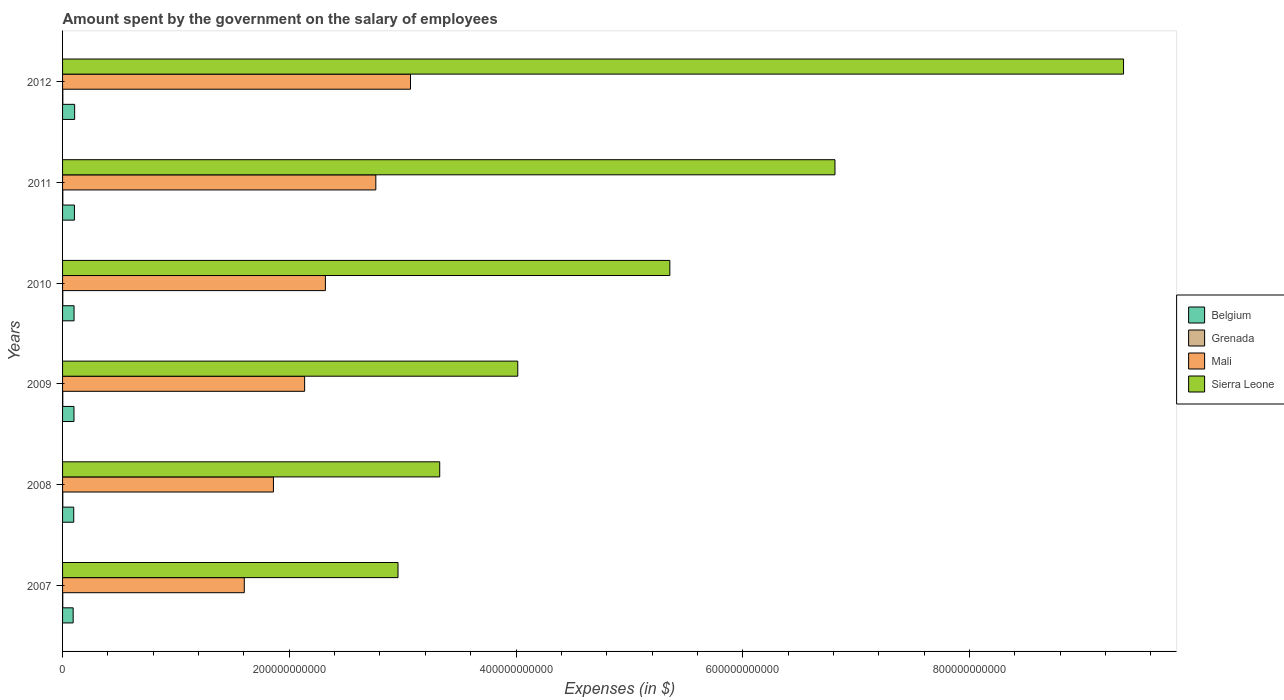How many different coloured bars are there?
Offer a terse response. 4. What is the label of the 4th group of bars from the top?
Provide a succinct answer. 2009. What is the amount spent on the salary of employees by the government in Sierra Leone in 2009?
Give a very brief answer. 4.02e+11. Across all years, what is the maximum amount spent on the salary of employees by the government in Belgium?
Offer a very short reply. 1.07e+1. Across all years, what is the minimum amount spent on the salary of employees by the government in Mali?
Your answer should be very brief. 1.60e+11. In which year was the amount spent on the salary of employees by the government in Mali maximum?
Ensure brevity in your answer.  2012. What is the total amount spent on the salary of employees by the government in Belgium in the graph?
Make the answer very short. 6.05e+1. What is the difference between the amount spent on the salary of employees by the government in Grenada in 2007 and that in 2011?
Provide a short and direct response. -6.32e+07. What is the difference between the amount spent on the salary of employees by the government in Mali in 2009 and the amount spent on the salary of employees by the government in Grenada in 2012?
Your answer should be compact. 2.13e+11. What is the average amount spent on the salary of employees by the government in Belgium per year?
Your answer should be compact. 1.01e+1. In the year 2012, what is the difference between the amount spent on the salary of employees by the government in Sierra Leone and amount spent on the salary of employees by the government in Grenada?
Keep it short and to the point. 9.36e+11. What is the ratio of the amount spent on the salary of employees by the government in Grenada in 2009 to that in 2010?
Give a very brief answer. 0.96. What is the difference between the highest and the second highest amount spent on the salary of employees by the government in Mali?
Offer a very short reply. 3.06e+1. What is the difference between the highest and the lowest amount spent on the salary of employees by the government in Grenada?
Provide a short and direct response. 6.88e+07. In how many years, is the amount spent on the salary of employees by the government in Sierra Leone greater than the average amount spent on the salary of employees by the government in Sierra Leone taken over all years?
Your answer should be compact. 3. Is it the case that in every year, the sum of the amount spent on the salary of employees by the government in Sierra Leone and amount spent on the salary of employees by the government in Mali is greater than the sum of amount spent on the salary of employees by the government in Grenada and amount spent on the salary of employees by the government in Belgium?
Offer a terse response. Yes. What does the 1st bar from the top in 2009 represents?
Provide a short and direct response. Sierra Leone. What does the 3rd bar from the bottom in 2007 represents?
Make the answer very short. Mali. Is it the case that in every year, the sum of the amount spent on the salary of employees by the government in Belgium and amount spent on the salary of employees by the government in Grenada is greater than the amount spent on the salary of employees by the government in Mali?
Your answer should be very brief. No. Are all the bars in the graph horizontal?
Offer a terse response. Yes. What is the difference between two consecutive major ticks on the X-axis?
Ensure brevity in your answer.  2.00e+11. Are the values on the major ticks of X-axis written in scientific E-notation?
Make the answer very short. No. Does the graph contain any zero values?
Your answer should be compact. No. Where does the legend appear in the graph?
Your response must be concise. Center right. What is the title of the graph?
Make the answer very short. Amount spent by the government on the salary of employees. Does "Small states" appear as one of the legend labels in the graph?
Offer a very short reply. No. What is the label or title of the X-axis?
Your answer should be compact. Expenses (in $). What is the Expenses (in $) in Belgium in 2007?
Offer a terse response. 9.34e+09. What is the Expenses (in $) of Grenada in 2007?
Keep it short and to the point. 1.58e+08. What is the Expenses (in $) in Mali in 2007?
Your answer should be very brief. 1.60e+11. What is the Expenses (in $) of Sierra Leone in 2007?
Keep it short and to the point. 2.96e+11. What is the Expenses (in $) of Belgium in 2008?
Ensure brevity in your answer.  9.86e+09. What is the Expenses (in $) of Grenada in 2008?
Offer a terse response. 2.01e+08. What is the Expenses (in $) of Mali in 2008?
Give a very brief answer. 1.86e+11. What is the Expenses (in $) in Sierra Leone in 2008?
Ensure brevity in your answer.  3.33e+11. What is the Expenses (in $) in Belgium in 2009?
Offer a very short reply. 1.01e+1. What is the Expenses (in $) of Grenada in 2009?
Ensure brevity in your answer.  1.91e+08. What is the Expenses (in $) in Mali in 2009?
Provide a succinct answer. 2.14e+11. What is the Expenses (in $) of Sierra Leone in 2009?
Give a very brief answer. 4.02e+11. What is the Expenses (in $) of Belgium in 2010?
Keep it short and to the point. 1.01e+1. What is the Expenses (in $) of Grenada in 2010?
Offer a terse response. 1.99e+08. What is the Expenses (in $) of Mali in 2010?
Your response must be concise. 2.32e+11. What is the Expenses (in $) in Sierra Leone in 2010?
Your answer should be very brief. 5.36e+11. What is the Expenses (in $) in Belgium in 2011?
Ensure brevity in your answer.  1.05e+1. What is the Expenses (in $) of Grenada in 2011?
Make the answer very short. 2.22e+08. What is the Expenses (in $) in Mali in 2011?
Give a very brief answer. 2.76e+11. What is the Expenses (in $) in Sierra Leone in 2011?
Your answer should be compact. 6.81e+11. What is the Expenses (in $) in Belgium in 2012?
Your answer should be compact. 1.07e+1. What is the Expenses (in $) of Grenada in 2012?
Your response must be concise. 2.27e+08. What is the Expenses (in $) of Mali in 2012?
Your answer should be compact. 3.07e+11. What is the Expenses (in $) of Sierra Leone in 2012?
Provide a short and direct response. 9.36e+11. Across all years, what is the maximum Expenses (in $) of Belgium?
Your answer should be compact. 1.07e+1. Across all years, what is the maximum Expenses (in $) of Grenada?
Provide a succinct answer. 2.27e+08. Across all years, what is the maximum Expenses (in $) in Mali?
Provide a succinct answer. 3.07e+11. Across all years, what is the maximum Expenses (in $) in Sierra Leone?
Give a very brief answer. 9.36e+11. Across all years, what is the minimum Expenses (in $) of Belgium?
Ensure brevity in your answer.  9.34e+09. Across all years, what is the minimum Expenses (in $) in Grenada?
Ensure brevity in your answer.  1.58e+08. Across all years, what is the minimum Expenses (in $) in Mali?
Your answer should be compact. 1.60e+11. Across all years, what is the minimum Expenses (in $) in Sierra Leone?
Your response must be concise. 2.96e+11. What is the total Expenses (in $) in Belgium in the graph?
Your answer should be very brief. 6.05e+1. What is the total Expenses (in $) of Grenada in the graph?
Your answer should be compact. 1.20e+09. What is the total Expenses (in $) of Mali in the graph?
Provide a short and direct response. 1.37e+12. What is the total Expenses (in $) of Sierra Leone in the graph?
Your response must be concise. 3.18e+12. What is the difference between the Expenses (in $) of Belgium in 2007 and that in 2008?
Your answer should be very brief. -5.14e+08. What is the difference between the Expenses (in $) in Grenada in 2007 and that in 2008?
Your response must be concise. -4.24e+07. What is the difference between the Expenses (in $) in Mali in 2007 and that in 2008?
Ensure brevity in your answer.  -2.57e+1. What is the difference between the Expenses (in $) of Sierra Leone in 2007 and that in 2008?
Give a very brief answer. -3.68e+1. What is the difference between the Expenses (in $) of Belgium in 2007 and that in 2009?
Make the answer very short. -7.34e+08. What is the difference between the Expenses (in $) in Grenada in 2007 and that in 2009?
Provide a succinct answer. -3.28e+07. What is the difference between the Expenses (in $) in Mali in 2007 and that in 2009?
Your answer should be compact. -5.32e+1. What is the difference between the Expenses (in $) of Sierra Leone in 2007 and that in 2009?
Ensure brevity in your answer.  -1.06e+11. What is the difference between the Expenses (in $) of Belgium in 2007 and that in 2010?
Your answer should be compact. -8.04e+08. What is the difference between the Expenses (in $) of Grenada in 2007 and that in 2010?
Give a very brief answer. -4.10e+07. What is the difference between the Expenses (in $) in Mali in 2007 and that in 2010?
Your response must be concise. -7.15e+1. What is the difference between the Expenses (in $) of Sierra Leone in 2007 and that in 2010?
Provide a short and direct response. -2.40e+11. What is the difference between the Expenses (in $) of Belgium in 2007 and that in 2011?
Give a very brief answer. -1.12e+09. What is the difference between the Expenses (in $) of Grenada in 2007 and that in 2011?
Your response must be concise. -6.32e+07. What is the difference between the Expenses (in $) in Mali in 2007 and that in 2011?
Keep it short and to the point. -1.16e+11. What is the difference between the Expenses (in $) in Sierra Leone in 2007 and that in 2011?
Offer a terse response. -3.85e+11. What is the difference between the Expenses (in $) of Belgium in 2007 and that in 2012?
Make the answer very short. -1.31e+09. What is the difference between the Expenses (in $) of Grenada in 2007 and that in 2012?
Your answer should be compact. -6.88e+07. What is the difference between the Expenses (in $) of Mali in 2007 and that in 2012?
Provide a succinct answer. -1.47e+11. What is the difference between the Expenses (in $) of Sierra Leone in 2007 and that in 2012?
Offer a terse response. -6.40e+11. What is the difference between the Expenses (in $) of Belgium in 2008 and that in 2009?
Keep it short and to the point. -2.20e+08. What is the difference between the Expenses (in $) of Grenada in 2008 and that in 2009?
Keep it short and to the point. 9.60e+06. What is the difference between the Expenses (in $) of Mali in 2008 and that in 2009?
Keep it short and to the point. -2.75e+1. What is the difference between the Expenses (in $) of Sierra Leone in 2008 and that in 2009?
Provide a succinct answer. -6.88e+1. What is the difference between the Expenses (in $) in Belgium in 2008 and that in 2010?
Your answer should be very brief. -2.89e+08. What is the difference between the Expenses (in $) in Grenada in 2008 and that in 2010?
Offer a very short reply. 1.40e+06. What is the difference between the Expenses (in $) of Mali in 2008 and that in 2010?
Your response must be concise. -4.58e+1. What is the difference between the Expenses (in $) of Sierra Leone in 2008 and that in 2010?
Offer a very short reply. -2.03e+11. What is the difference between the Expenses (in $) in Belgium in 2008 and that in 2011?
Your response must be concise. -6.05e+08. What is the difference between the Expenses (in $) in Grenada in 2008 and that in 2011?
Provide a short and direct response. -2.08e+07. What is the difference between the Expenses (in $) of Mali in 2008 and that in 2011?
Offer a very short reply. -9.03e+1. What is the difference between the Expenses (in $) in Sierra Leone in 2008 and that in 2011?
Your response must be concise. -3.49e+11. What is the difference between the Expenses (in $) of Belgium in 2008 and that in 2012?
Provide a succinct answer. -7.94e+08. What is the difference between the Expenses (in $) of Grenada in 2008 and that in 2012?
Make the answer very short. -2.64e+07. What is the difference between the Expenses (in $) in Mali in 2008 and that in 2012?
Provide a succinct answer. -1.21e+11. What is the difference between the Expenses (in $) of Sierra Leone in 2008 and that in 2012?
Your response must be concise. -6.03e+11. What is the difference between the Expenses (in $) in Belgium in 2009 and that in 2010?
Your response must be concise. -6.91e+07. What is the difference between the Expenses (in $) of Grenada in 2009 and that in 2010?
Provide a succinct answer. -8.20e+06. What is the difference between the Expenses (in $) in Mali in 2009 and that in 2010?
Ensure brevity in your answer.  -1.83e+1. What is the difference between the Expenses (in $) in Sierra Leone in 2009 and that in 2010?
Make the answer very short. -1.34e+11. What is the difference between the Expenses (in $) of Belgium in 2009 and that in 2011?
Offer a very short reply. -3.85e+08. What is the difference between the Expenses (in $) in Grenada in 2009 and that in 2011?
Provide a succinct answer. -3.04e+07. What is the difference between the Expenses (in $) of Mali in 2009 and that in 2011?
Ensure brevity in your answer.  -6.28e+1. What is the difference between the Expenses (in $) of Sierra Leone in 2009 and that in 2011?
Make the answer very short. -2.80e+11. What is the difference between the Expenses (in $) of Belgium in 2009 and that in 2012?
Your response must be concise. -5.74e+08. What is the difference between the Expenses (in $) of Grenada in 2009 and that in 2012?
Offer a terse response. -3.60e+07. What is the difference between the Expenses (in $) in Mali in 2009 and that in 2012?
Your answer should be compact. -9.34e+1. What is the difference between the Expenses (in $) of Sierra Leone in 2009 and that in 2012?
Make the answer very short. -5.34e+11. What is the difference between the Expenses (in $) in Belgium in 2010 and that in 2011?
Your answer should be very brief. -3.16e+08. What is the difference between the Expenses (in $) of Grenada in 2010 and that in 2011?
Your response must be concise. -2.22e+07. What is the difference between the Expenses (in $) of Mali in 2010 and that in 2011?
Ensure brevity in your answer.  -4.45e+1. What is the difference between the Expenses (in $) of Sierra Leone in 2010 and that in 2011?
Offer a very short reply. -1.46e+11. What is the difference between the Expenses (in $) of Belgium in 2010 and that in 2012?
Ensure brevity in your answer.  -5.04e+08. What is the difference between the Expenses (in $) in Grenada in 2010 and that in 2012?
Ensure brevity in your answer.  -2.78e+07. What is the difference between the Expenses (in $) in Mali in 2010 and that in 2012?
Offer a very short reply. -7.51e+1. What is the difference between the Expenses (in $) of Sierra Leone in 2010 and that in 2012?
Your answer should be compact. -4.00e+11. What is the difference between the Expenses (in $) of Belgium in 2011 and that in 2012?
Ensure brevity in your answer.  -1.89e+08. What is the difference between the Expenses (in $) in Grenada in 2011 and that in 2012?
Provide a succinct answer. -5.60e+06. What is the difference between the Expenses (in $) in Mali in 2011 and that in 2012?
Your answer should be compact. -3.06e+1. What is the difference between the Expenses (in $) in Sierra Leone in 2011 and that in 2012?
Ensure brevity in your answer.  -2.55e+11. What is the difference between the Expenses (in $) of Belgium in 2007 and the Expenses (in $) of Grenada in 2008?
Offer a terse response. 9.14e+09. What is the difference between the Expenses (in $) in Belgium in 2007 and the Expenses (in $) in Mali in 2008?
Keep it short and to the point. -1.77e+11. What is the difference between the Expenses (in $) in Belgium in 2007 and the Expenses (in $) in Sierra Leone in 2008?
Offer a terse response. -3.23e+11. What is the difference between the Expenses (in $) in Grenada in 2007 and the Expenses (in $) in Mali in 2008?
Ensure brevity in your answer.  -1.86e+11. What is the difference between the Expenses (in $) of Grenada in 2007 and the Expenses (in $) of Sierra Leone in 2008?
Your answer should be very brief. -3.33e+11. What is the difference between the Expenses (in $) in Mali in 2007 and the Expenses (in $) in Sierra Leone in 2008?
Your answer should be compact. -1.72e+11. What is the difference between the Expenses (in $) of Belgium in 2007 and the Expenses (in $) of Grenada in 2009?
Your response must be concise. 9.15e+09. What is the difference between the Expenses (in $) of Belgium in 2007 and the Expenses (in $) of Mali in 2009?
Your answer should be compact. -2.04e+11. What is the difference between the Expenses (in $) of Belgium in 2007 and the Expenses (in $) of Sierra Leone in 2009?
Offer a terse response. -3.92e+11. What is the difference between the Expenses (in $) in Grenada in 2007 and the Expenses (in $) in Mali in 2009?
Provide a succinct answer. -2.13e+11. What is the difference between the Expenses (in $) of Grenada in 2007 and the Expenses (in $) of Sierra Leone in 2009?
Your response must be concise. -4.01e+11. What is the difference between the Expenses (in $) in Mali in 2007 and the Expenses (in $) in Sierra Leone in 2009?
Make the answer very short. -2.41e+11. What is the difference between the Expenses (in $) in Belgium in 2007 and the Expenses (in $) in Grenada in 2010?
Ensure brevity in your answer.  9.14e+09. What is the difference between the Expenses (in $) in Belgium in 2007 and the Expenses (in $) in Mali in 2010?
Offer a very short reply. -2.22e+11. What is the difference between the Expenses (in $) of Belgium in 2007 and the Expenses (in $) of Sierra Leone in 2010?
Keep it short and to the point. -5.26e+11. What is the difference between the Expenses (in $) of Grenada in 2007 and the Expenses (in $) of Mali in 2010?
Offer a terse response. -2.32e+11. What is the difference between the Expenses (in $) of Grenada in 2007 and the Expenses (in $) of Sierra Leone in 2010?
Offer a terse response. -5.36e+11. What is the difference between the Expenses (in $) of Mali in 2007 and the Expenses (in $) of Sierra Leone in 2010?
Ensure brevity in your answer.  -3.75e+11. What is the difference between the Expenses (in $) in Belgium in 2007 and the Expenses (in $) in Grenada in 2011?
Your answer should be very brief. 9.12e+09. What is the difference between the Expenses (in $) in Belgium in 2007 and the Expenses (in $) in Mali in 2011?
Provide a short and direct response. -2.67e+11. What is the difference between the Expenses (in $) in Belgium in 2007 and the Expenses (in $) in Sierra Leone in 2011?
Provide a short and direct response. -6.72e+11. What is the difference between the Expenses (in $) in Grenada in 2007 and the Expenses (in $) in Mali in 2011?
Your response must be concise. -2.76e+11. What is the difference between the Expenses (in $) in Grenada in 2007 and the Expenses (in $) in Sierra Leone in 2011?
Offer a very short reply. -6.81e+11. What is the difference between the Expenses (in $) in Mali in 2007 and the Expenses (in $) in Sierra Leone in 2011?
Offer a very short reply. -5.21e+11. What is the difference between the Expenses (in $) of Belgium in 2007 and the Expenses (in $) of Grenada in 2012?
Ensure brevity in your answer.  9.12e+09. What is the difference between the Expenses (in $) of Belgium in 2007 and the Expenses (in $) of Mali in 2012?
Ensure brevity in your answer.  -2.98e+11. What is the difference between the Expenses (in $) of Belgium in 2007 and the Expenses (in $) of Sierra Leone in 2012?
Your answer should be very brief. -9.27e+11. What is the difference between the Expenses (in $) in Grenada in 2007 and the Expenses (in $) in Mali in 2012?
Your answer should be very brief. -3.07e+11. What is the difference between the Expenses (in $) in Grenada in 2007 and the Expenses (in $) in Sierra Leone in 2012?
Offer a very short reply. -9.36e+11. What is the difference between the Expenses (in $) of Mali in 2007 and the Expenses (in $) of Sierra Leone in 2012?
Provide a succinct answer. -7.76e+11. What is the difference between the Expenses (in $) in Belgium in 2008 and the Expenses (in $) in Grenada in 2009?
Offer a very short reply. 9.67e+09. What is the difference between the Expenses (in $) of Belgium in 2008 and the Expenses (in $) of Mali in 2009?
Provide a short and direct response. -2.04e+11. What is the difference between the Expenses (in $) in Belgium in 2008 and the Expenses (in $) in Sierra Leone in 2009?
Provide a short and direct response. -3.92e+11. What is the difference between the Expenses (in $) of Grenada in 2008 and the Expenses (in $) of Mali in 2009?
Provide a succinct answer. -2.13e+11. What is the difference between the Expenses (in $) in Grenada in 2008 and the Expenses (in $) in Sierra Leone in 2009?
Offer a terse response. -4.01e+11. What is the difference between the Expenses (in $) of Mali in 2008 and the Expenses (in $) of Sierra Leone in 2009?
Make the answer very short. -2.16e+11. What is the difference between the Expenses (in $) of Belgium in 2008 and the Expenses (in $) of Grenada in 2010?
Offer a terse response. 9.66e+09. What is the difference between the Expenses (in $) in Belgium in 2008 and the Expenses (in $) in Mali in 2010?
Give a very brief answer. -2.22e+11. What is the difference between the Expenses (in $) of Belgium in 2008 and the Expenses (in $) of Sierra Leone in 2010?
Your answer should be compact. -5.26e+11. What is the difference between the Expenses (in $) in Grenada in 2008 and the Expenses (in $) in Mali in 2010?
Provide a succinct answer. -2.32e+11. What is the difference between the Expenses (in $) of Grenada in 2008 and the Expenses (in $) of Sierra Leone in 2010?
Provide a short and direct response. -5.35e+11. What is the difference between the Expenses (in $) in Mali in 2008 and the Expenses (in $) in Sierra Leone in 2010?
Ensure brevity in your answer.  -3.50e+11. What is the difference between the Expenses (in $) in Belgium in 2008 and the Expenses (in $) in Grenada in 2011?
Offer a very short reply. 9.64e+09. What is the difference between the Expenses (in $) in Belgium in 2008 and the Expenses (in $) in Mali in 2011?
Your answer should be compact. -2.66e+11. What is the difference between the Expenses (in $) in Belgium in 2008 and the Expenses (in $) in Sierra Leone in 2011?
Provide a succinct answer. -6.71e+11. What is the difference between the Expenses (in $) in Grenada in 2008 and the Expenses (in $) in Mali in 2011?
Your answer should be very brief. -2.76e+11. What is the difference between the Expenses (in $) of Grenada in 2008 and the Expenses (in $) of Sierra Leone in 2011?
Provide a succinct answer. -6.81e+11. What is the difference between the Expenses (in $) in Mali in 2008 and the Expenses (in $) in Sierra Leone in 2011?
Provide a succinct answer. -4.95e+11. What is the difference between the Expenses (in $) of Belgium in 2008 and the Expenses (in $) of Grenada in 2012?
Give a very brief answer. 9.63e+09. What is the difference between the Expenses (in $) of Belgium in 2008 and the Expenses (in $) of Mali in 2012?
Give a very brief answer. -2.97e+11. What is the difference between the Expenses (in $) in Belgium in 2008 and the Expenses (in $) in Sierra Leone in 2012?
Make the answer very short. -9.26e+11. What is the difference between the Expenses (in $) of Grenada in 2008 and the Expenses (in $) of Mali in 2012?
Provide a succinct answer. -3.07e+11. What is the difference between the Expenses (in $) of Grenada in 2008 and the Expenses (in $) of Sierra Leone in 2012?
Offer a terse response. -9.36e+11. What is the difference between the Expenses (in $) of Mali in 2008 and the Expenses (in $) of Sierra Leone in 2012?
Keep it short and to the point. -7.50e+11. What is the difference between the Expenses (in $) in Belgium in 2009 and the Expenses (in $) in Grenada in 2010?
Provide a succinct answer. 9.88e+09. What is the difference between the Expenses (in $) in Belgium in 2009 and the Expenses (in $) in Mali in 2010?
Your answer should be compact. -2.22e+11. What is the difference between the Expenses (in $) in Belgium in 2009 and the Expenses (in $) in Sierra Leone in 2010?
Provide a short and direct response. -5.26e+11. What is the difference between the Expenses (in $) in Grenada in 2009 and the Expenses (in $) in Mali in 2010?
Give a very brief answer. -2.32e+11. What is the difference between the Expenses (in $) in Grenada in 2009 and the Expenses (in $) in Sierra Leone in 2010?
Your answer should be very brief. -5.35e+11. What is the difference between the Expenses (in $) in Mali in 2009 and the Expenses (in $) in Sierra Leone in 2010?
Your answer should be compact. -3.22e+11. What is the difference between the Expenses (in $) of Belgium in 2009 and the Expenses (in $) of Grenada in 2011?
Offer a very short reply. 9.86e+09. What is the difference between the Expenses (in $) in Belgium in 2009 and the Expenses (in $) in Mali in 2011?
Ensure brevity in your answer.  -2.66e+11. What is the difference between the Expenses (in $) of Belgium in 2009 and the Expenses (in $) of Sierra Leone in 2011?
Ensure brevity in your answer.  -6.71e+11. What is the difference between the Expenses (in $) in Grenada in 2009 and the Expenses (in $) in Mali in 2011?
Ensure brevity in your answer.  -2.76e+11. What is the difference between the Expenses (in $) in Grenada in 2009 and the Expenses (in $) in Sierra Leone in 2011?
Your answer should be very brief. -6.81e+11. What is the difference between the Expenses (in $) of Mali in 2009 and the Expenses (in $) of Sierra Leone in 2011?
Make the answer very short. -4.68e+11. What is the difference between the Expenses (in $) in Belgium in 2009 and the Expenses (in $) in Grenada in 2012?
Give a very brief answer. 9.85e+09. What is the difference between the Expenses (in $) in Belgium in 2009 and the Expenses (in $) in Mali in 2012?
Offer a very short reply. -2.97e+11. What is the difference between the Expenses (in $) of Belgium in 2009 and the Expenses (in $) of Sierra Leone in 2012?
Ensure brevity in your answer.  -9.26e+11. What is the difference between the Expenses (in $) of Grenada in 2009 and the Expenses (in $) of Mali in 2012?
Provide a succinct answer. -3.07e+11. What is the difference between the Expenses (in $) of Grenada in 2009 and the Expenses (in $) of Sierra Leone in 2012?
Your answer should be compact. -9.36e+11. What is the difference between the Expenses (in $) of Mali in 2009 and the Expenses (in $) of Sierra Leone in 2012?
Make the answer very short. -7.22e+11. What is the difference between the Expenses (in $) of Belgium in 2010 and the Expenses (in $) of Grenada in 2011?
Offer a very short reply. 9.92e+09. What is the difference between the Expenses (in $) in Belgium in 2010 and the Expenses (in $) in Mali in 2011?
Provide a short and direct response. -2.66e+11. What is the difference between the Expenses (in $) in Belgium in 2010 and the Expenses (in $) in Sierra Leone in 2011?
Ensure brevity in your answer.  -6.71e+11. What is the difference between the Expenses (in $) of Grenada in 2010 and the Expenses (in $) of Mali in 2011?
Provide a short and direct response. -2.76e+11. What is the difference between the Expenses (in $) of Grenada in 2010 and the Expenses (in $) of Sierra Leone in 2011?
Offer a terse response. -6.81e+11. What is the difference between the Expenses (in $) in Mali in 2010 and the Expenses (in $) in Sierra Leone in 2011?
Provide a succinct answer. -4.50e+11. What is the difference between the Expenses (in $) of Belgium in 2010 and the Expenses (in $) of Grenada in 2012?
Ensure brevity in your answer.  9.92e+09. What is the difference between the Expenses (in $) in Belgium in 2010 and the Expenses (in $) in Mali in 2012?
Your response must be concise. -2.97e+11. What is the difference between the Expenses (in $) in Belgium in 2010 and the Expenses (in $) in Sierra Leone in 2012?
Make the answer very short. -9.26e+11. What is the difference between the Expenses (in $) in Grenada in 2010 and the Expenses (in $) in Mali in 2012?
Your response must be concise. -3.07e+11. What is the difference between the Expenses (in $) in Grenada in 2010 and the Expenses (in $) in Sierra Leone in 2012?
Give a very brief answer. -9.36e+11. What is the difference between the Expenses (in $) of Mali in 2010 and the Expenses (in $) of Sierra Leone in 2012?
Your response must be concise. -7.04e+11. What is the difference between the Expenses (in $) of Belgium in 2011 and the Expenses (in $) of Grenada in 2012?
Give a very brief answer. 1.02e+1. What is the difference between the Expenses (in $) in Belgium in 2011 and the Expenses (in $) in Mali in 2012?
Offer a very short reply. -2.96e+11. What is the difference between the Expenses (in $) in Belgium in 2011 and the Expenses (in $) in Sierra Leone in 2012?
Your response must be concise. -9.25e+11. What is the difference between the Expenses (in $) of Grenada in 2011 and the Expenses (in $) of Mali in 2012?
Make the answer very short. -3.07e+11. What is the difference between the Expenses (in $) of Grenada in 2011 and the Expenses (in $) of Sierra Leone in 2012?
Provide a short and direct response. -9.36e+11. What is the difference between the Expenses (in $) of Mali in 2011 and the Expenses (in $) of Sierra Leone in 2012?
Your response must be concise. -6.60e+11. What is the average Expenses (in $) in Belgium per year?
Keep it short and to the point. 1.01e+1. What is the average Expenses (in $) in Grenada per year?
Keep it short and to the point. 2.00e+08. What is the average Expenses (in $) in Mali per year?
Your answer should be compact. 2.29e+11. What is the average Expenses (in $) in Sierra Leone per year?
Your response must be concise. 5.31e+11. In the year 2007, what is the difference between the Expenses (in $) of Belgium and Expenses (in $) of Grenada?
Ensure brevity in your answer.  9.18e+09. In the year 2007, what is the difference between the Expenses (in $) in Belgium and Expenses (in $) in Mali?
Give a very brief answer. -1.51e+11. In the year 2007, what is the difference between the Expenses (in $) in Belgium and Expenses (in $) in Sierra Leone?
Give a very brief answer. -2.87e+11. In the year 2007, what is the difference between the Expenses (in $) in Grenada and Expenses (in $) in Mali?
Provide a succinct answer. -1.60e+11. In the year 2007, what is the difference between the Expenses (in $) in Grenada and Expenses (in $) in Sierra Leone?
Give a very brief answer. -2.96e+11. In the year 2007, what is the difference between the Expenses (in $) of Mali and Expenses (in $) of Sierra Leone?
Your response must be concise. -1.36e+11. In the year 2008, what is the difference between the Expenses (in $) in Belgium and Expenses (in $) in Grenada?
Offer a terse response. 9.66e+09. In the year 2008, what is the difference between the Expenses (in $) in Belgium and Expenses (in $) in Mali?
Offer a very short reply. -1.76e+11. In the year 2008, what is the difference between the Expenses (in $) in Belgium and Expenses (in $) in Sierra Leone?
Offer a terse response. -3.23e+11. In the year 2008, what is the difference between the Expenses (in $) of Grenada and Expenses (in $) of Mali?
Give a very brief answer. -1.86e+11. In the year 2008, what is the difference between the Expenses (in $) in Grenada and Expenses (in $) in Sierra Leone?
Make the answer very short. -3.32e+11. In the year 2008, what is the difference between the Expenses (in $) of Mali and Expenses (in $) of Sierra Leone?
Give a very brief answer. -1.47e+11. In the year 2009, what is the difference between the Expenses (in $) of Belgium and Expenses (in $) of Grenada?
Offer a terse response. 9.89e+09. In the year 2009, what is the difference between the Expenses (in $) of Belgium and Expenses (in $) of Mali?
Offer a very short reply. -2.03e+11. In the year 2009, what is the difference between the Expenses (in $) of Belgium and Expenses (in $) of Sierra Leone?
Offer a very short reply. -3.91e+11. In the year 2009, what is the difference between the Expenses (in $) in Grenada and Expenses (in $) in Mali?
Make the answer very short. -2.13e+11. In the year 2009, what is the difference between the Expenses (in $) of Grenada and Expenses (in $) of Sierra Leone?
Offer a terse response. -4.01e+11. In the year 2009, what is the difference between the Expenses (in $) in Mali and Expenses (in $) in Sierra Leone?
Keep it short and to the point. -1.88e+11. In the year 2010, what is the difference between the Expenses (in $) of Belgium and Expenses (in $) of Grenada?
Your answer should be compact. 9.95e+09. In the year 2010, what is the difference between the Expenses (in $) in Belgium and Expenses (in $) in Mali?
Give a very brief answer. -2.22e+11. In the year 2010, what is the difference between the Expenses (in $) in Belgium and Expenses (in $) in Sierra Leone?
Provide a short and direct response. -5.26e+11. In the year 2010, what is the difference between the Expenses (in $) of Grenada and Expenses (in $) of Mali?
Your response must be concise. -2.32e+11. In the year 2010, what is the difference between the Expenses (in $) in Grenada and Expenses (in $) in Sierra Leone?
Your answer should be compact. -5.35e+11. In the year 2010, what is the difference between the Expenses (in $) of Mali and Expenses (in $) of Sierra Leone?
Your answer should be compact. -3.04e+11. In the year 2011, what is the difference between the Expenses (in $) of Belgium and Expenses (in $) of Grenada?
Offer a very short reply. 1.02e+1. In the year 2011, what is the difference between the Expenses (in $) in Belgium and Expenses (in $) in Mali?
Make the answer very short. -2.66e+11. In the year 2011, what is the difference between the Expenses (in $) of Belgium and Expenses (in $) of Sierra Leone?
Provide a succinct answer. -6.71e+11. In the year 2011, what is the difference between the Expenses (in $) in Grenada and Expenses (in $) in Mali?
Offer a very short reply. -2.76e+11. In the year 2011, what is the difference between the Expenses (in $) in Grenada and Expenses (in $) in Sierra Leone?
Offer a terse response. -6.81e+11. In the year 2011, what is the difference between the Expenses (in $) in Mali and Expenses (in $) in Sierra Leone?
Offer a terse response. -4.05e+11. In the year 2012, what is the difference between the Expenses (in $) in Belgium and Expenses (in $) in Grenada?
Provide a succinct answer. 1.04e+1. In the year 2012, what is the difference between the Expenses (in $) in Belgium and Expenses (in $) in Mali?
Provide a short and direct response. -2.96e+11. In the year 2012, what is the difference between the Expenses (in $) of Belgium and Expenses (in $) of Sierra Leone?
Your answer should be very brief. -9.25e+11. In the year 2012, what is the difference between the Expenses (in $) of Grenada and Expenses (in $) of Mali?
Give a very brief answer. -3.07e+11. In the year 2012, what is the difference between the Expenses (in $) of Grenada and Expenses (in $) of Sierra Leone?
Provide a succinct answer. -9.36e+11. In the year 2012, what is the difference between the Expenses (in $) of Mali and Expenses (in $) of Sierra Leone?
Keep it short and to the point. -6.29e+11. What is the ratio of the Expenses (in $) in Belgium in 2007 to that in 2008?
Keep it short and to the point. 0.95. What is the ratio of the Expenses (in $) in Grenada in 2007 to that in 2008?
Provide a short and direct response. 0.79. What is the ratio of the Expenses (in $) of Mali in 2007 to that in 2008?
Give a very brief answer. 0.86. What is the ratio of the Expenses (in $) of Sierra Leone in 2007 to that in 2008?
Offer a terse response. 0.89. What is the ratio of the Expenses (in $) of Belgium in 2007 to that in 2009?
Your response must be concise. 0.93. What is the ratio of the Expenses (in $) of Grenada in 2007 to that in 2009?
Your answer should be very brief. 0.83. What is the ratio of the Expenses (in $) of Mali in 2007 to that in 2009?
Provide a short and direct response. 0.75. What is the ratio of the Expenses (in $) of Sierra Leone in 2007 to that in 2009?
Your answer should be compact. 0.74. What is the ratio of the Expenses (in $) in Belgium in 2007 to that in 2010?
Ensure brevity in your answer.  0.92. What is the ratio of the Expenses (in $) of Grenada in 2007 to that in 2010?
Make the answer very short. 0.79. What is the ratio of the Expenses (in $) in Mali in 2007 to that in 2010?
Your answer should be very brief. 0.69. What is the ratio of the Expenses (in $) of Sierra Leone in 2007 to that in 2010?
Ensure brevity in your answer.  0.55. What is the ratio of the Expenses (in $) of Belgium in 2007 to that in 2011?
Provide a short and direct response. 0.89. What is the ratio of the Expenses (in $) in Grenada in 2007 to that in 2011?
Your response must be concise. 0.71. What is the ratio of the Expenses (in $) of Mali in 2007 to that in 2011?
Ensure brevity in your answer.  0.58. What is the ratio of the Expenses (in $) in Sierra Leone in 2007 to that in 2011?
Give a very brief answer. 0.43. What is the ratio of the Expenses (in $) of Belgium in 2007 to that in 2012?
Your answer should be very brief. 0.88. What is the ratio of the Expenses (in $) in Grenada in 2007 to that in 2012?
Make the answer very short. 0.7. What is the ratio of the Expenses (in $) in Mali in 2007 to that in 2012?
Keep it short and to the point. 0.52. What is the ratio of the Expenses (in $) in Sierra Leone in 2007 to that in 2012?
Give a very brief answer. 0.32. What is the ratio of the Expenses (in $) in Belgium in 2008 to that in 2009?
Keep it short and to the point. 0.98. What is the ratio of the Expenses (in $) of Grenada in 2008 to that in 2009?
Your answer should be compact. 1.05. What is the ratio of the Expenses (in $) of Mali in 2008 to that in 2009?
Offer a very short reply. 0.87. What is the ratio of the Expenses (in $) of Sierra Leone in 2008 to that in 2009?
Your answer should be compact. 0.83. What is the ratio of the Expenses (in $) of Belgium in 2008 to that in 2010?
Make the answer very short. 0.97. What is the ratio of the Expenses (in $) in Mali in 2008 to that in 2010?
Offer a terse response. 0.8. What is the ratio of the Expenses (in $) of Sierra Leone in 2008 to that in 2010?
Your answer should be compact. 0.62. What is the ratio of the Expenses (in $) in Belgium in 2008 to that in 2011?
Provide a short and direct response. 0.94. What is the ratio of the Expenses (in $) in Grenada in 2008 to that in 2011?
Your answer should be very brief. 0.91. What is the ratio of the Expenses (in $) in Mali in 2008 to that in 2011?
Offer a very short reply. 0.67. What is the ratio of the Expenses (in $) in Sierra Leone in 2008 to that in 2011?
Ensure brevity in your answer.  0.49. What is the ratio of the Expenses (in $) in Belgium in 2008 to that in 2012?
Your response must be concise. 0.93. What is the ratio of the Expenses (in $) in Grenada in 2008 to that in 2012?
Your answer should be compact. 0.88. What is the ratio of the Expenses (in $) of Mali in 2008 to that in 2012?
Offer a terse response. 0.61. What is the ratio of the Expenses (in $) in Sierra Leone in 2008 to that in 2012?
Your answer should be very brief. 0.36. What is the ratio of the Expenses (in $) in Grenada in 2009 to that in 2010?
Keep it short and to the point. 0.96. What is the ratio of the Expenses (in $) in Mali in 2009 to that in 2010?
Keep it short and to the point. 0.92. What is the ratio of the Expenses (in $) in Sierra Leone in 2009 to that in 2010?
Provide a short and direct response. 0.75. What is the ratio of the Expenses (in $) in Belgium in 2009 to that in 2011?
Provide a short and direct response. 0.96. What is the ratio of the Expenses (in $) in Grenada in 2009 to that in 2011?
Ensure brevity in your answer.  0.86. What is the ratio of the Expenses (in $) of Mali in 2009 to that in 2011?
Make the answer very short. 0.77. What is the ratio of the Expenses (in $) in Sierra Leone in 2009 to that in 2011?
Keep it short and to the point. 0.59. What is the ratio of the Expenses (in $) of Belgium in 2009 to that in 2012?
Your answer should be compact. 0.95. What is the ratio of the Expenses (in $) in Grenada in 2009 to that in 2012?
Provide a succinct answer. 0.84. What is the ratio of the Expenses (in $) of Mali in 2009 to that in 2012?
Provide a short and direct response. 0.7. What is the ratio of the Expenses (in $) in Sierra Leone in 2009 to that in 2012?
Your answer should be compact. 0.43. What is the ratio of the Expenses (in $) of Belgium in 2010 to that in 2011?
Offer a terse response. 0.97. What is the ratio of the Expenses (in $) of Grenada in 2010 to that in 2011?
Offer a terse response. 0.9. What is the ratio of the Expenses (in $) in Mali in 2010 to that in 2011?
Offer a very short reply. 0.84. What is the ratio of the Expenses (in $) in Sierra Leone in 2010 to that in 2011?
Give a very brief answer. 0.79. What is the ratio of the Expenses (in $) in Belgium in 2010 to that in 2012?
Provide a succinct answer. 0.95. What is the ratio of the Expenses (in $) in Grenada in 2010 to that in 2012?
Offer a very short reply. 0.88. What is the ratio of the Expenses (in $) in Mali in 2010 to that in 2012?
Offer a very short reply. 0.76. What is the ratio of the Expenses (in $) in Sierra Leone in 2010 to that in 2012?
Your response must be concise. 0.57. What is the ratio of the Expenses (in $) in Belgium in 2011 to that in 2012?
Provide a succinct answer. 0.98. What is the ratio of the Expenses (in $) in Grenada in 2011 to that in 2012?
Make the answer very short. 0.98. What is the ratio of the Expenses (in $) in Mali in 2011 to that in 2012?
Offer a very short reply. 0.9. What is the ratio of the Expenses (in $) of Sierra Leone in 2011 to that in 2012?
Keep it short and to the point. 0.73. What is the difference between the highest and the second highest Expenses (in $) in Belgium?
Make the answer very short. 1.89e+08. What is the difference between the highest and the second highest Expenses (in $) of Grenada?
Provide a short and direct response. 5.60e+06. What is the difference between the highest and the second highest Expenses (in $) of Mali?
Your answer should be compact. 3.06e+1. What is the difference between the highest and the second highest Expenses (in $) of Sierra Leone?
Provide a succinct answer. 2.55e+11. What is the difference between the highest and the lowest Expenses (in $) in Belgium?
Give a very brief answer. 1.31e+09. What is the difference between the highest and the lowest Expenses (in $) of Grenada?
Your answer should be compact. 6.88e+07. What is the difference between the highest and the lowest Expenses (in $) of Mali?
Make the answer very short. 1.47e+11. What is the difference between the highest and the lowest Expenses (in $) of Sierra Leone?
Keep it short and to the point. 6.40e+11. 